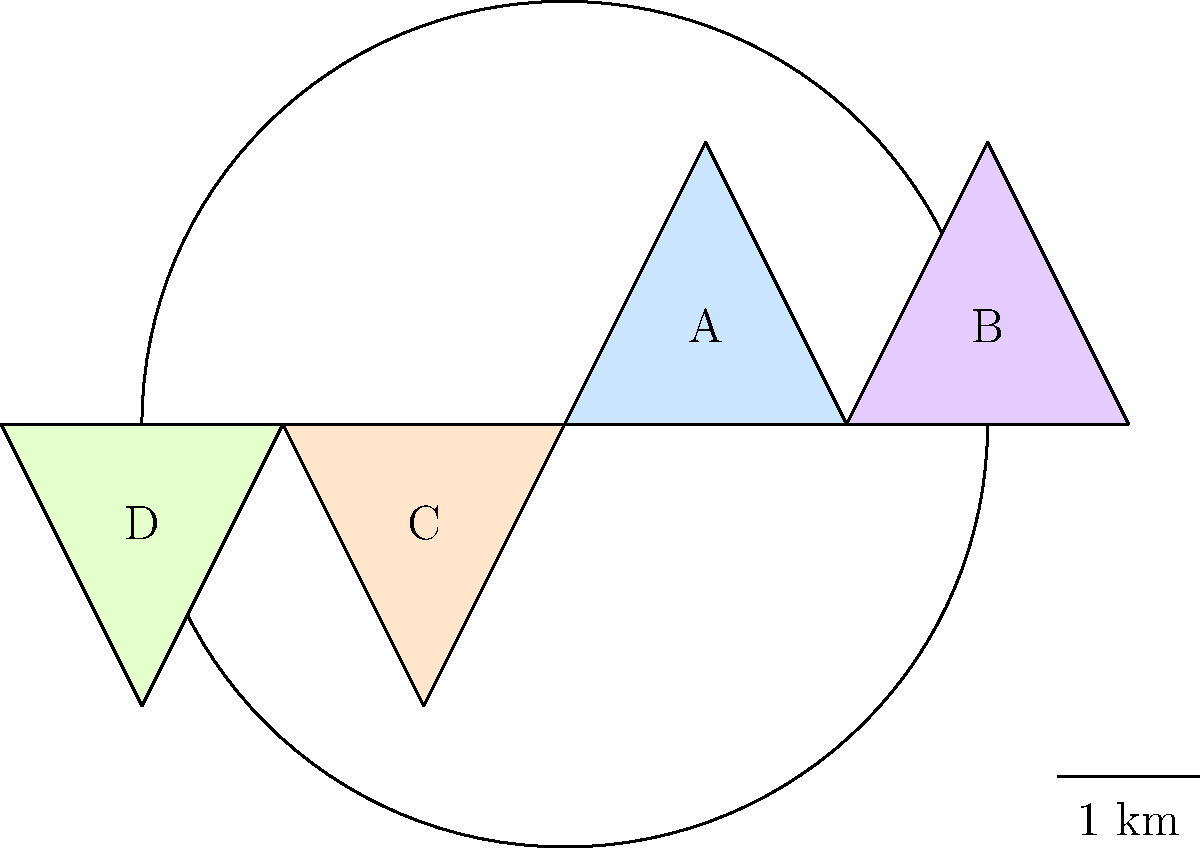In the map above, which voting district appears to have the most irregular shape that could potentially indicate gerrymandering? To analyze the voting districts for potential gerrymandering, we need to examine each district's shape and compare them:

1. District A: This district has a triangular shape with relatively straight boundaries.
2. District B: Similar to District A, it has a triangular shape with straight boundaries.
3. District C: Also triangular with straight boundaries, mirroring District A.
4. District D: This district has a triangular shape but with slightly curved boundaries, particularly on its left side.

When looking for signs of gerrymandering, we typically search for:
- Irregular shapes
- Elongated districts
- Districts with appendages or protrusions

Among the four districts, District D stands out as having a slightly more irregular shape due to its curved left boundary. This curvature could potentially indicate an attempt to include or exclude certain populations, which is a common tactic in gerrymandering.

However, it's important to note that:
1. The irregularity in District D is relatively minor.
2. Irregular shapes alone do not definitively prove gerrymandering.
3. Natural geography, such as rivers or mountains, can sometimes cause irregular district shapes.

As a skeptical politics reporter, it's crucial to investigate further before drawing any conclusions about potential election fraud or gerrymandering based solely on this map.
Answer: District D 